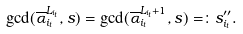<formula> <loc_0><loc_0><loc_500><loc_500>\gcd ( \overline { \alpha } _ { i _ { t } } ^ { L _ { i _ { t } } } , s ) = \gcd ( \overline { \alpha } _ { i _ { t } } ^ { L _ { i _ { t } } + 1 } , s ) = \colon s ^ { \prime \prime } _ { i _ { t } } .</formula> 